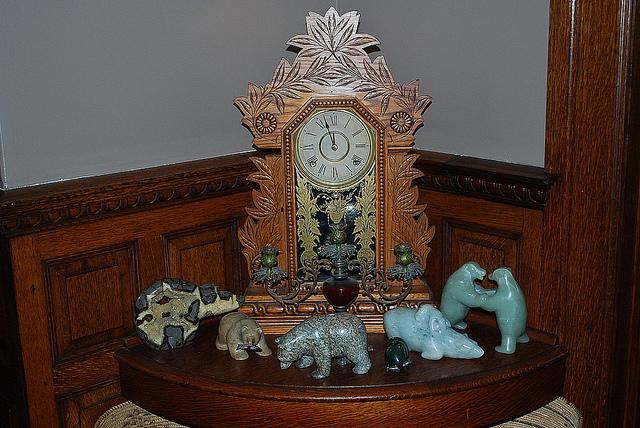What material are the two bears to the right of the desk clock made from? Please explain your reasoning. jade. This was a common material used to make these types of collectibles historically. that said, c was also then eventually used to mimic a. 